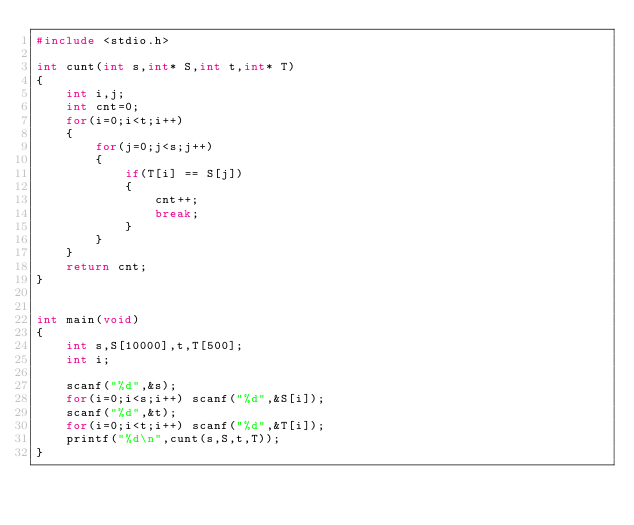<code> <loc_0><loc_0><loc_500><loc_500><_C_>#include <stdio.h>
 
int cunt(int s,int* S,int t,int* T)
{
    int i,j;
    int cnt=0;
    for(i=0;i<t;i++)
    {
        for(j=0;j<s;j++)
        {
            if(T[i] == S[j])
            {
                cnt++;
                break;
            }
        }
    }
    return cnt;
}
 
 
int main(void)
{
    int s,S[10000],t,T[500];
    int i;
     
    scanf("%d",&s);
    for(i=0;i<s;i++) scanf("%d",&S[i]);
    scanf("%d",&t);
    for(i=0;i<t;i++) scanf("%d",&T[i]);
    printf("%d\n",cunt(s,S,t,T));
}
</code> 